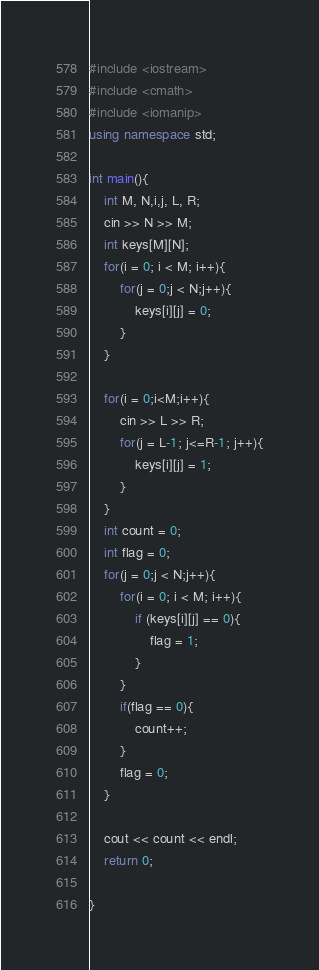Convert code to text. <code><loc_0><loc_0><loc_500><loc_500><_C++_>#include <iostream>
#include <cmath>
#include <iomanip>
using namespace std;

int main(){
    int M, N,i,j, L, R;
    cin >> N >> M;
    int keys[M][N];
    for(i = 0; i < M; i++){
        for(j = 0;j < N;j++){
            keys[i][j] = 0;
        }
    }

    for(i = 0;i<M;i++){
        cin >> L >> R;
        for(j = L-1; j<=R-1; j++){
            keys[i][j] = 1;
        }
    }
    int count = 0;
    int flag = 0;
    for(j = 0;j < N;j++){
        for(i = 0; i < M; i++){
            if (keys[i][j] == 0){
                flag = 1;
            }
        }
        if(flag == 0){
            count++;
        }
        flag = 0;
    }

    cout << count << endl;
    return 0;

}</code> 